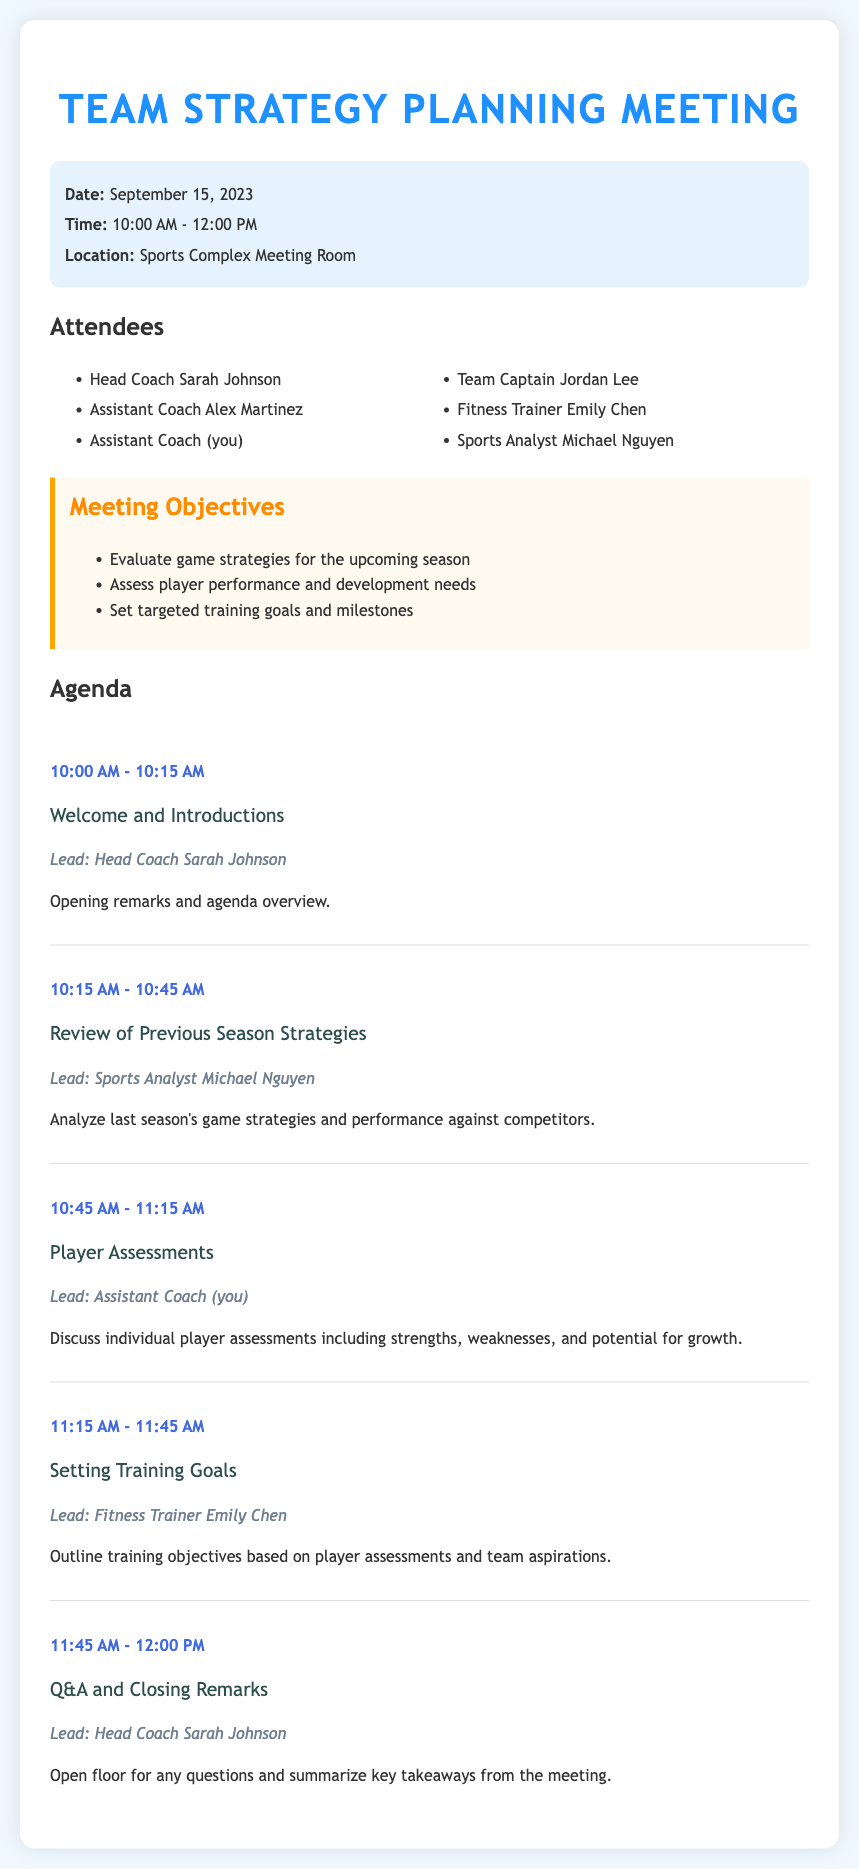What is the date of the meeting? The meeting date is stated in the document as September 15, 2023.
Answer: September 15, 2023 Who is leading the agenda item on Player Assessments? The document specifies that the Assistant Coach (you) will lead the discussion on Player Assessments.
Answer: Assistant Coach (you) What time does the Q&A session start? The schedule shows that the Q&A session begins at 11:45 AM.
Answer: 11:45 AM What is one of the meeting objectives? The document lists various objectives, including evaluating game strategies for the upcoming season.
Answer: Evaluate game strategies for the upcoming season How long is the Review of Previous Season Strategies discussion? The agenda indicates that this discussion is allocated 30 minutes, from 10:15 AM to 10:45 AM.
Answer: 30 minutes What location is specified for the meeting? The document states that the meeting will take place in the Sports Complex Meeting Room.
Answer: Sports Complex Meeting Room What is the total duration of the meeting? The meeting starts at 10:00 AM and ends at 12:00 PM, making it a total of 2 hours.
Answer: 2 hours Who is responsible for setting training goals? According to the agenda, Fitness Trainer Emily Chen will outline the training objectives.
Answer: Fitness Trainer Emily Chen 